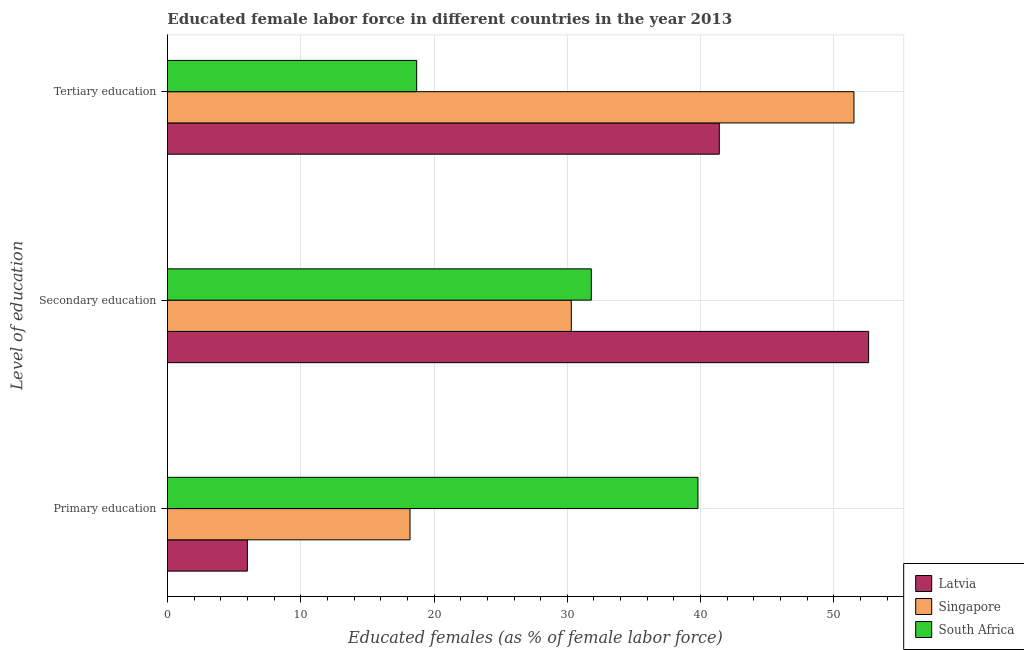How many different coloured bars are there?
Keep it short and to the point. 3. What is the label of the 1st group of bars from the top?
Your answer should be compact. Tertiary education. What is the percentage of female labor force who received secondary education in South Africa?
Make the answer very short. 31.8. Across all countries, what is the maximum percentage of female labor force who received tertiary education?
Your answer should be very brief. 51.5. Across all countries, what is the minimum percentage of female labor force who received tertiary education?
Keep it short and to the point. 18.7. In which country was the percentage of female labor force who received tertiary education maximum?
Give a very brief answer. Singapore. In which country was the percentage of female labor force who received primary education minimum?
Your response must be concise. Latvia. What is the difference between the percentage of female labor force who received secondary education in Latvia and that in South Africa?
Your response must be concise. 20.8. What is the difference between the percentage of female labor force who received secondary education in Latvia and the percentage of female labor force who received primary education in Singapore?
Give a very brief answer. 34.4. What is the average percentage of female labor force who received primary education per country?
Your answer should be very brief. 21.33. What is the difference between the percentage of female labor force who received secondary education and percentage of female labor force who received primary education in South Africa?
Ensure brevity in your answer.  -8. In how many countries, is the percentage of female labor force who received secondary education greater than 38 %?
Your answer should be very brief. 1. What is the ratio of the percentage of female labor force who received tertiary education in Latvia to that in Singapore?
Make the answer very short. 0.8. Is the percentage of female labor force who received tertiary education in Latvia less than that in Singapore?
Offer a terse response. Yes. Is the difference between the percentage of female labor force who received tertiary education in Singapore and Latvia greater than the difference between the percentage of female labor force who received secondary education in Singapore and Latvia?
Offer a very short reply. Yes. What is the difference between the highest and the second highest percentage of female labor force who received tertiary education?
Provide a short and direct response. 10.1. What is the difference between the highest and the lowest percentage of female labor force who received secondary education?
Your answer should be very brief. 22.3. What does the 1st bar from the top in Primary education represents?
Your answer should be very brief. South Africa. What does the 2nd bar from the bottom in Primary education represents?
Your answer should be very brief. Singapore. Is it the case that in every country, the sum of the percentage of female labor force who received primary education and percentage of female labor force who received secondary education is greater than the percentage of female labor force who received tertiary education?
Offer a terse response. No. How many bars are there?
Your response must be concise. 9. What is the difference between two consecutive major ticks on the X-axis?
Your response must be concise. 10. How many legend labels are there?
Your response must be concise. 3. How are the legend labels stacked?
Your answer should be compact. Vertical. What is the title of the graph?
Keep it short and to the point. Educated female labor force in different countries in the year 2013. Does "Greenland" appear as one of the legend labels in the graph?
Ensure brevity in your answer.  No. What is the label or title of the X-axis?
Give a very brief answer. Educated females (as % of female labor force). What is the label or title of the Y-axis?
Keep it short and to the point. Level of education. What is the Educated females (as % of female labor force) of Latvia in Primary education?
Offer a terse response. 6. What is the Educated females (as % of female labor force) of Singapore in Primary education?
Keep it short and to the point. 18.2. What is the Educated females (as % of female labor force) of South Africa in Primary education?
Your answer should be compact. 39.8. What is the Educated females (as % of female labor force) in Latvia in Secondary education?
Make the answer very short. 52.6. What is the Educated females (as % of female labor force) of Singapore in Secondary education?
Give a very brief answer. 30.3. What is the Educated females (as % of female labor force) of South Africa in Secondary education?
Keep it short and to the point. 31.8. What is the Educated females (as % of female labor force) of Latvia in Tertiary education?
Keep it short and to the point. 41.4. What is the Educated females (as % of female labor force) of Singapore in Tertiary education?
Ensure brevity in your answer.  51.5. What is the Educated females (as % of female labor force) of South Africa in Tertiary education?
Ensure brevity in your answer.  18.7. Across all Level of education, what is the maximum Educated females (as % of female labor force) of Latvia?
Make the answer very short. 52.6. Across all Level of education, what is the maximum Educated females (as % of female labor force) in Singapore?
Keep it short and to the point. 51.5. Across all Level of education, what is the maximum Educated females (as % of female labor force) of South Africa?
Offer a very short reply. 39.8. Across all Level of education, what is the minimum Educated females (as % of female labor force) in Singapore?
Offer a terse response. 18.2. Across all Level of education, what is the minimum Educated females (as % of female labor force) in South Africa?
Your answer should be very brief. 18.7. What is the total Educated females (as % of female labor force) in Singapore in the graph?
Your answer should be very brief. 100. What is the total Educated females (as % of female labor force) in South Africa in the graph?
Provide a short and direct response. 90.3. What is the difference between the Educated females (as % of female labor force) of Latvia in Primary education and that in Secondary education?
Provide a succinct answer. -46.6. What is the difference between the Educated females (as % of female labor force) of Latvia in Primary education and that in Tertiary education?
Ensure brevity in your answer.  -35.4. What is the difference between the Educated females (as % of female labor force) of Singapore in Primary education and that in Tertiary education?
Provide a succinct answer. -33.3. What is the difference between the Educated females (as % of female labor force) of South Africa in Primary education and that in Tertiary education?
Give a very brief answer. 21.1. What is the difference between the Educated females (as % of female labor force) in Latvia in Secondary education and that in Tertiary education?
Give a very brief answer. 11.2. What is the difference between the Educated females (as % of female labor force) of Singapore in Secondary education and that in Tertiary education?
Your answer should be very brief. -21.2. What is the difference between the Educated females (as % of female labor force) of South Africa in Secondary education and that in Tertiary education?
Your answer should be very brief. 13.1. What is the difference between the Educated females (as % of female labor force) in Latvia in Primary education and the Educated females (as % of female labor force) in Singapore in Secondary education?
Offer a terse response. -24.3. What is the difference between the Educated females (as % of female labor force) in Latvia in Primary education and the Educated females (as % of female labor force) in South Africa in Secondary education?
Provide a succinct answer. -25.8. What is the difference between the Educated females (as % of female labor force) in Singapore in Primary education and the Educated females (as % of female labor force) in South Africa in Secondary education?
Provide a succinct answer. -13.6. What is the difference between the Educated females (as % of female labor force) in Latvia in Primary education and the Educated females (as % of female labor force) in Singapore in Tertiary education?
Your answer should be compact. -45.5. What is the difference between the Educated females (as % of female labor force) of Latvia in Secondary education and the Educated females (as % of female labor force) of South Africa in Tertiary education?
Provide a short and direct response. 33.9. What is the difference between the Educated females (as % of female labor force) in Singapore in Secondary education and the Educated females (as % of female labor force) in South Africa in Tertiary education?
Provide a short and direct response. 11.6. What is the average Educated females (as % of female labor force) in Latvia per Level of education?
Give a very brief answer. 33.33. What is the average Educated females (as % of female labor force) of Singapore per Level of education?
Offer a terse response. 33.33. What is the average Educated females (as % of female labor force) in South Africa per Level of education?
Provide a short and direct response. 30.1. What is the difference between the Educated females (as % of female labor force) of Latvia and Educated females (as % of female labor force) of South Africa in Primary education?
Offer a very short reply. -33.8. What is the difference between the Educated females (as % of female labor force) in Singapore and Educated females (as % of female labor force) in South Africa in Primary education?
Give a very brief answer. -21.6. What is the difference between the Educated females (as % of female labor force) in Latvia and Educated females (as % of female labor force) in Singapore in Secondary education?
Your response must be concise. 22.3. What is the difference between the Educated females (as % of female labor force) of Latvia and Educated females (as % of female labor force) of South Africa in Secondary education?
Offer a very short reply. 20.8. What is the difference between the Educated females (as % of female labor force) of Singapore and Educated females (as % of female labor force) of South Africa in Secondary education?
Provide a short and direct response. -1.5. What is the difference between the Educated females (as % of female labor force) in Latvia and Educated females (as % of female labor force) in Singapore in Tertiary education?
Provide a succinct answer. -10.1. What is the difference between the Educated females (as % of female labor force) in Latvia and Educated females (as % of female labor force) in South Africa in Tertiary education?
Offer a very short reply. 22.7. What is the difference between the Educated females (as % of female labor force) in Singapore and Educated females (as % of female labor force) in South Africa in Tertiary education?
Make the answer very short. 32.8. What is the ratio of the Educated females (as % of female labor force) in Latvia in Primary education to that in Secondary education?
Your answer should be very brief. 0.11. What is the ratio of the Educated females (as % of female labor force) of Singapore in Primary education to that in Secondary education?
Offer a terse response. 0.6. What is the ratio of the Educated females (as % of female labor force) in South Africa in Primary education to that in Secondary education?
Provide a short and direct response. 1.25. What is the ratio of the Educated females (as % of female labor force) in Latvia in Primary education to that in Tertiary education?
Offer a terse response. 0.14. What is the ratio of the Educated females (as % of female labor force) in Singapore in Primary education to that in Tertiary education?
Keep it short and to the point. 0.35. What is the ratio of the Educated females (as % of female labor force) of South Africa in Primary education to that in Tertiary education?
Provide a succinct answer. 2.13. What is the ratio of the Educated females (as % of female labor force) in Latvia in Secondary education to that in Tertiary education?
Offer a very short reply. 1.27. What is the ratio of the Educated females (as % of female labor force) in Singapore in Secondary education to that in Tertiary education?
Your answer should be very brief. 0.59. What is the ratio of the Educated females (as % of female labor force) in South Africa in Secondary education to that in Tertiary education?
Keep it short and to the point. 1.7. What is the difference between the highest and the second highest Educated females (as % of female labor force) of Singapore?
Give a very brief answer. 21.2. What is the difference between the highest and the second highest Educated females (as % of female labor force) in South Africa?
Your answer should be compact. 8. What is the difference between the highest and the lowest Educated females (as % of female labor force) in Latvia?
Your answer should be compact. 46.6. What is the difference between the highest and the lowest Educated females (as % of female labor force) of Singapore?
Provide a succinct answer. 33.3. What is the difference between the highest and the lowest Educated females (as % of female labor force) in South Africa?
Your answer should be very brief. 21.1. 